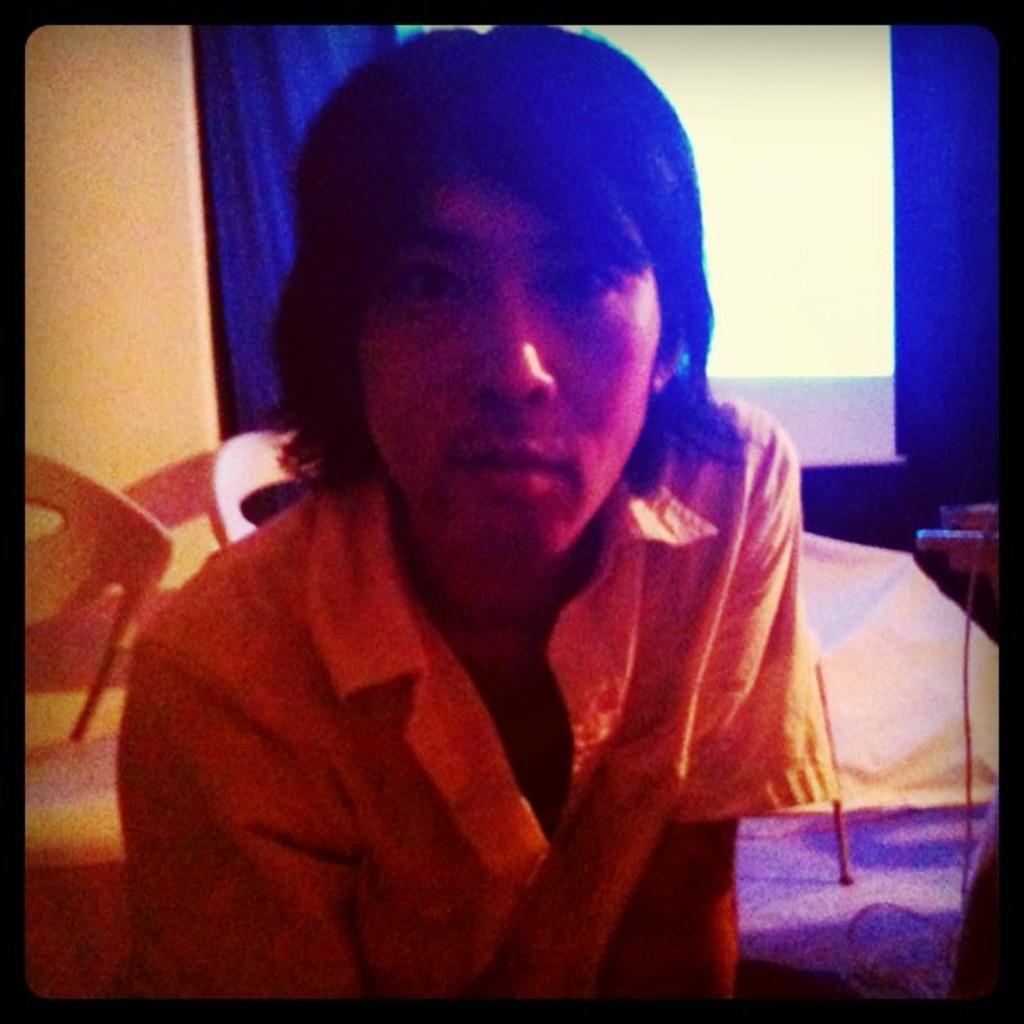Please provide a concise description of this image. In the image in the center we can see one person is sitting. In the background there is a wall,curtain,window,carpet,blanket,chairs and few other objects. And we can see the black border around the image. 